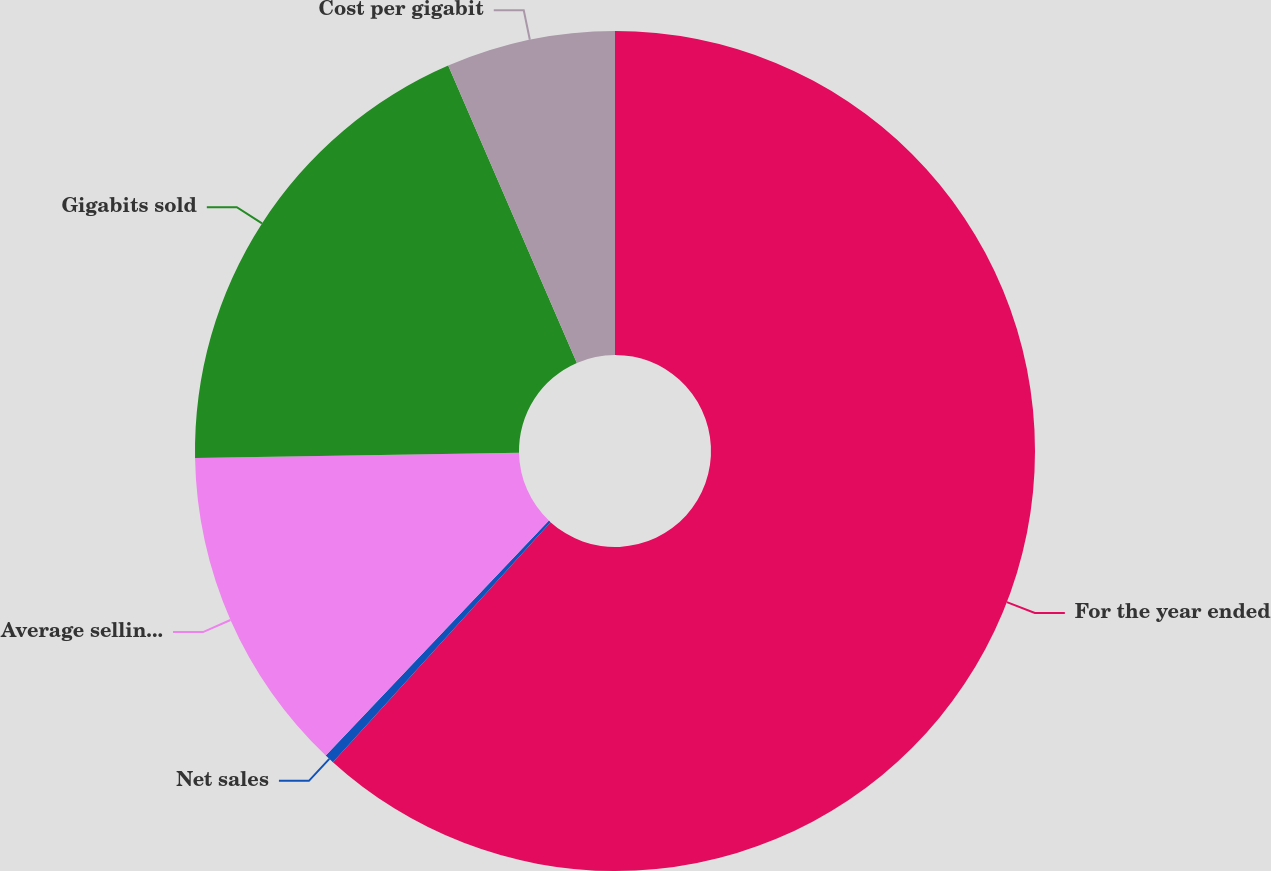<chart> <loc_0><loc_0><loc_500><loc_500><pie_chart><fcel>For the year ended<fcel>Net sales<fcel>Average selling prices per<fcel>Gigabits sold<fcel>Cost per gigabit<nl><fcel>61.72%<fcel>0.37%<fcel>12.64%<fcel>18.77%<fcel>6.5%<nl></chart> 